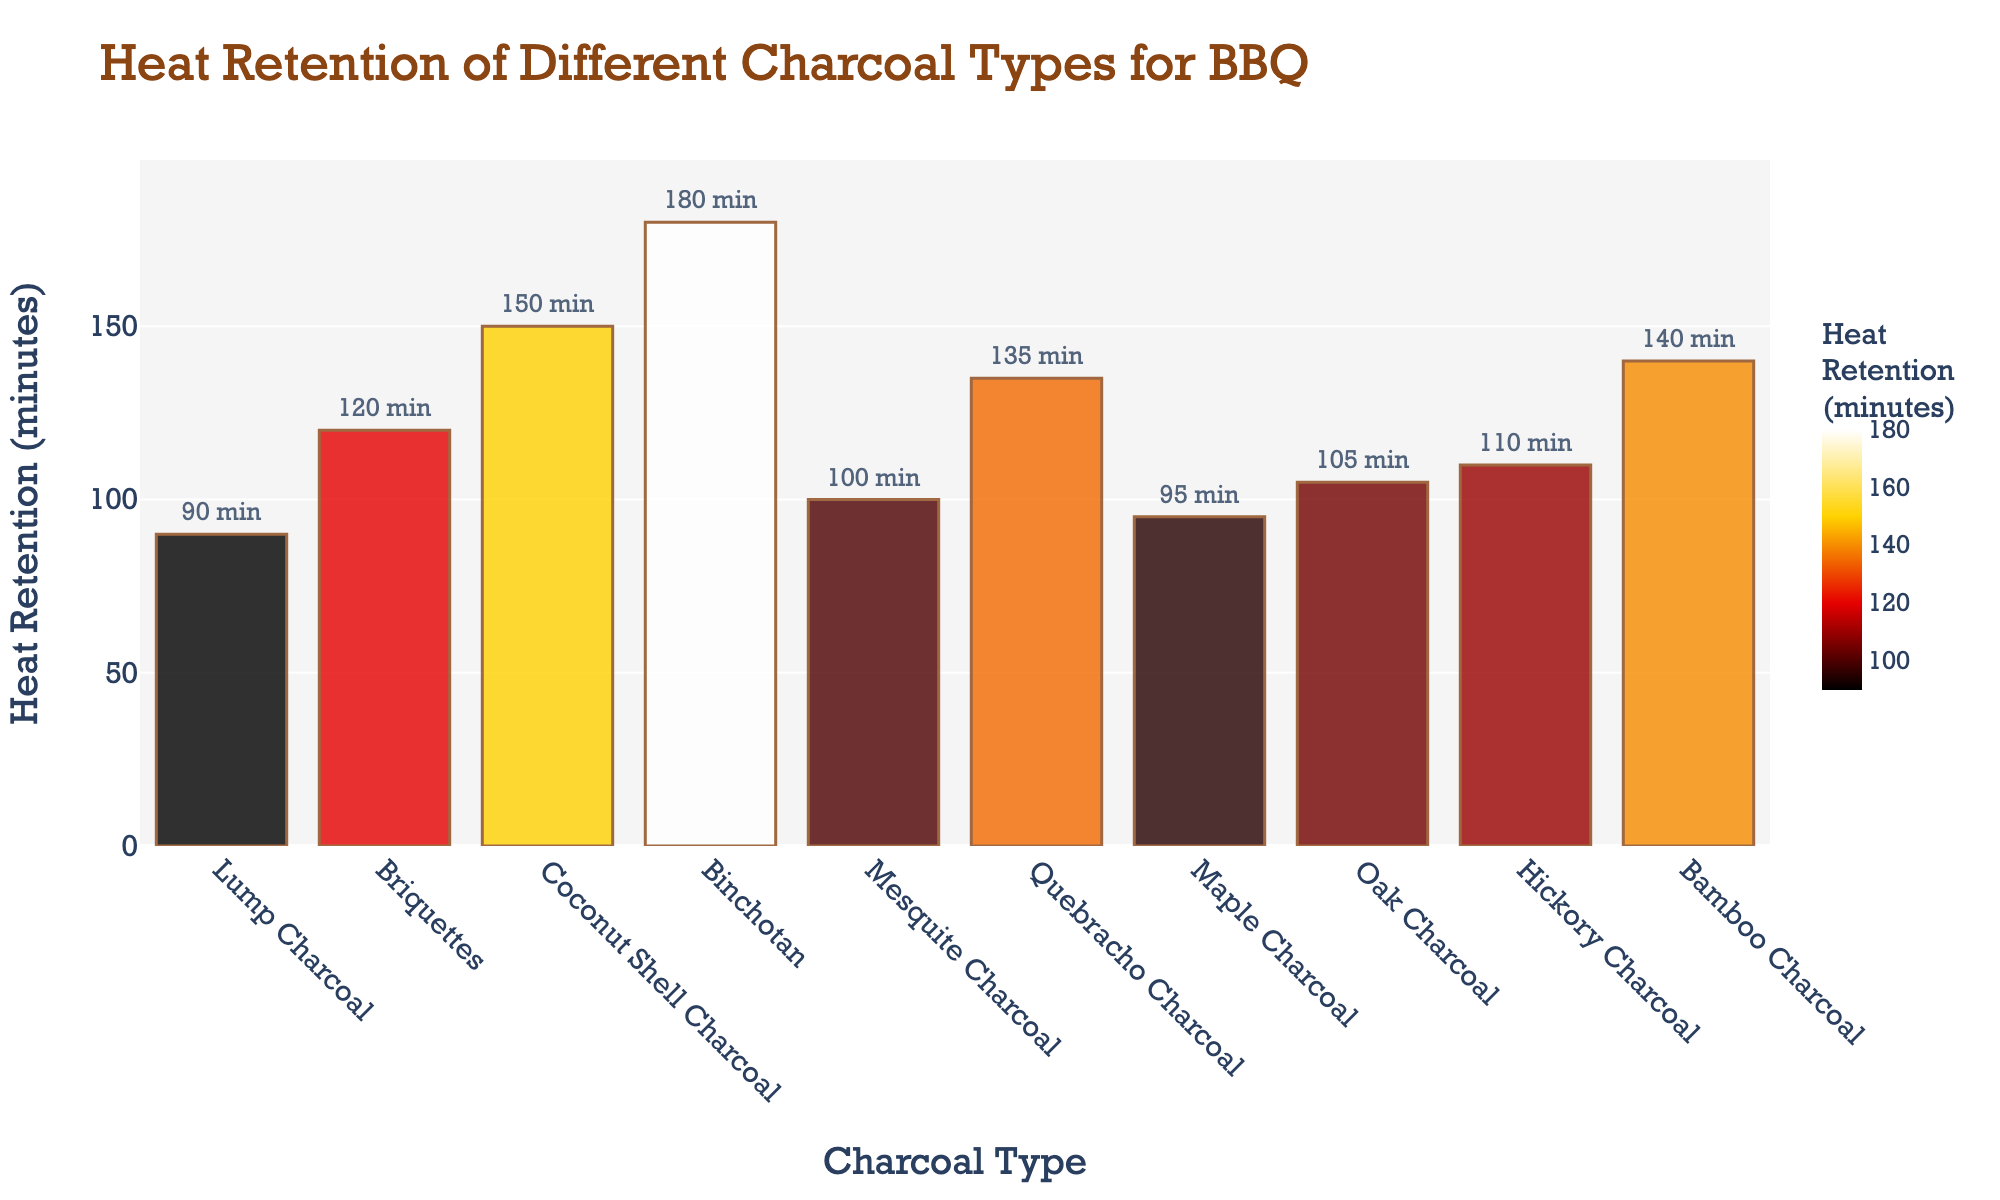Which charcoal type has the highest heat retention? The bar chart visually shows that Binchotan has the highest heat retention, indicated by the tallest bar reaching 180 minutes.
Answer: Binchotan Which charcoal type has the lowest heat retention? By observing the shortest bar, which indicates the lowest heat retention, we see that Lump Charcoal has the lowest value with 90 minutes.
Answer: Lump Charcoal How much more heat retention does Binchotan have compared to Lump Charcoal? First, identify the heat retention of Binchotan (180 minutes) and Lump Charcoal (90 minutes). Then calculate the difference: 180 - 90 = 90.
Answer: 90 minutes What is the average heat retention of all the charcoal types? Sum all the heat retentions: 90 + 120 + 150 + 180 + 100 + 135 + 95 + 105 + 110 + 140 = 1225. Dividing by the number of types (10), the average is 1225 / 10 = 122.5.
Answer: 122.5 minutes Which charcoal types have heat retention greater than 130 minutes? By locating the bars with values above 130 minutes, we see that Coconut Shell Charcoal (150), Binchotan (180), Quebracho Charcoal (135), and Bamboo Charcoal (140) surpass the 130-minute mark.
Answer: Coconut Shell Charcoal, Binchotan, Quebracho Charcoal, Bamboo Charcoal What is the difference in heat retention between Oak Charcoal and Maple Charcoal? Find the heat retentions of Oak Charcoal (105 minutes) and Maple Charcoal (95 minutes), then compute the difference: 105 - 95 = 10.
Answer: 10 minutes Which charcoal type has the closest heat retention to the median value? To find the median, list the times in ascending order: 90, 95, 100, 105, 110, 120, 130, 135, 140, 150, 180. The median is the middle value, which is 110. Hickory Charcoal has 110 minutes.
Answer: Hickory Charcoal Which two charcoal types have heat retentions whose total sums to 250 minutes? Reviewing the data, Lump Charcoal (90) + Quebracho Charcoal (135) sum to 225, Briquettes (120) + Maple Charcoal (95) sum to 215, Mesquite Charcoal (100) + Bamboo Charcoal (140) sum to 240, and Coconut Shell Charcoal (150) + Oak Charcoal (105) sum to 255. However, there is no exact pair summing to 250 based on this data.
Answer: None Which charcoal types have a heat retention that falls within the range of 100 to 140 minutes? Observing the bars within this range, the types are Mesquite Charcoal (100), Maple Charcoal (95), Oak Charcoal (105), Hickory Charcoal (110), Quebracho Charcoal (135), and Bamboo Charcoal (140).
Answer: Mesquite Charcoal, Oak Charcoal, Hickory Charcoal, Quebracho Charcoal, Bamboo Charcoal 